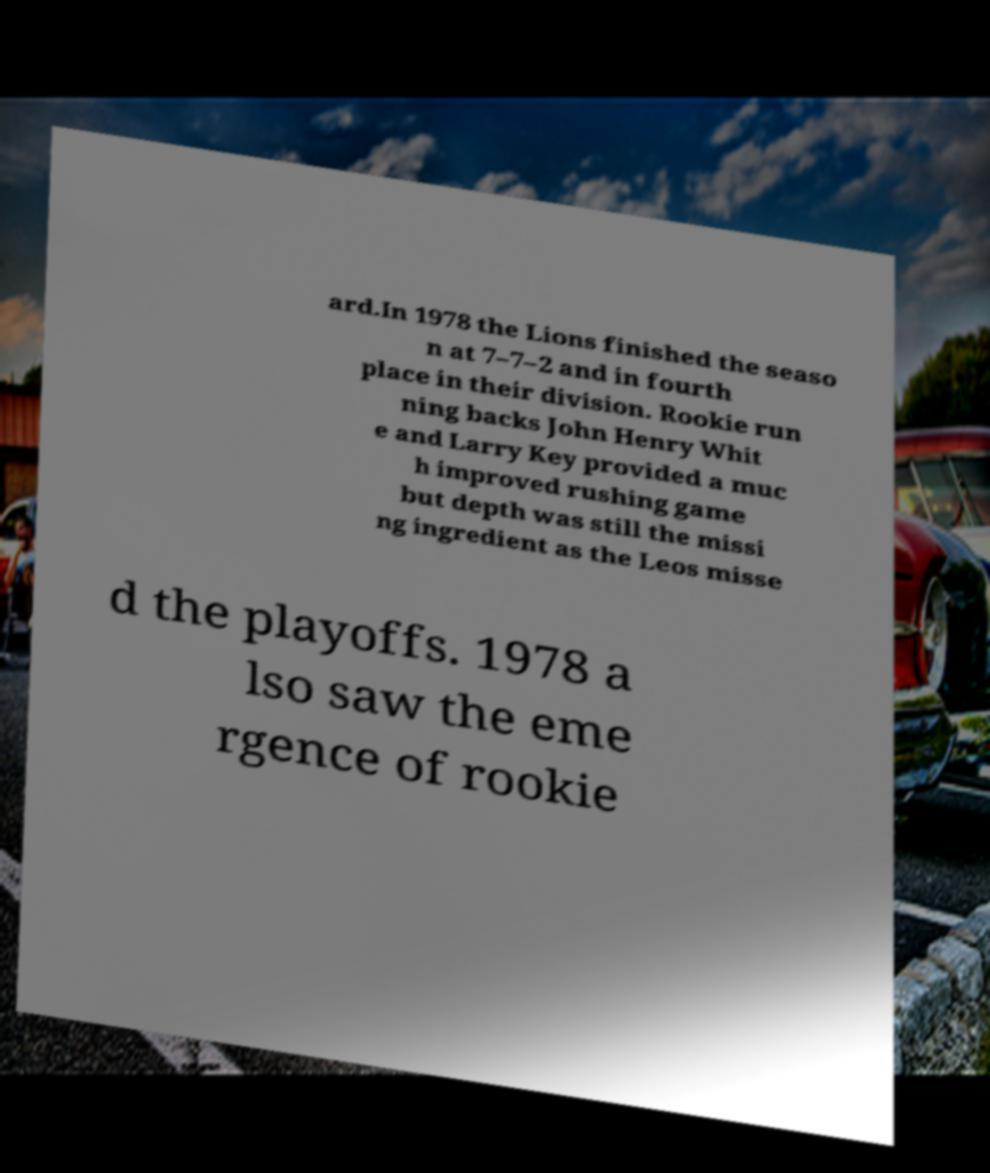Can you accurately transcribe the text from the provided image for me? ard.In 1978 the Lions finished the seaso n at 7–7–2 and in fourth place in their division. Rookie run ning backs John Henry Whit e and Larry Key provided a muc h improved rushing game but depth was still the missi ng ingredient as the Leos misse d the playoffs. 1978 a lso saw the eme rgence of rookie 